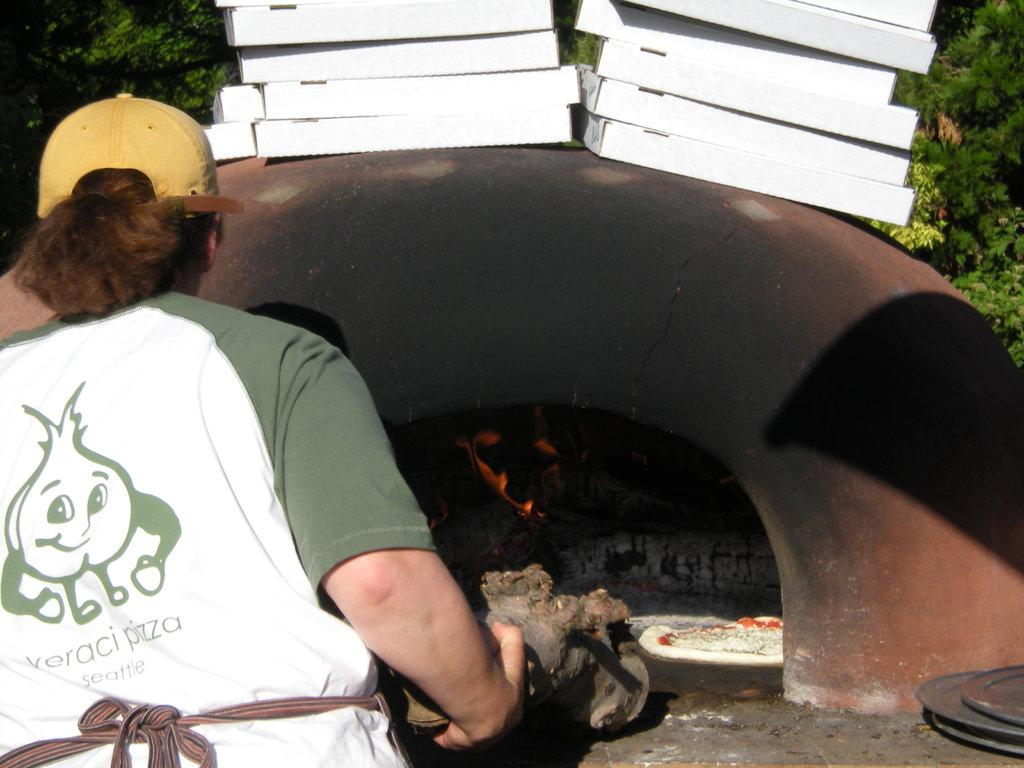<image>
Present a compact description of the photo's key features. A woman standing in front of an oven with a Veraci Pizza shirt on 